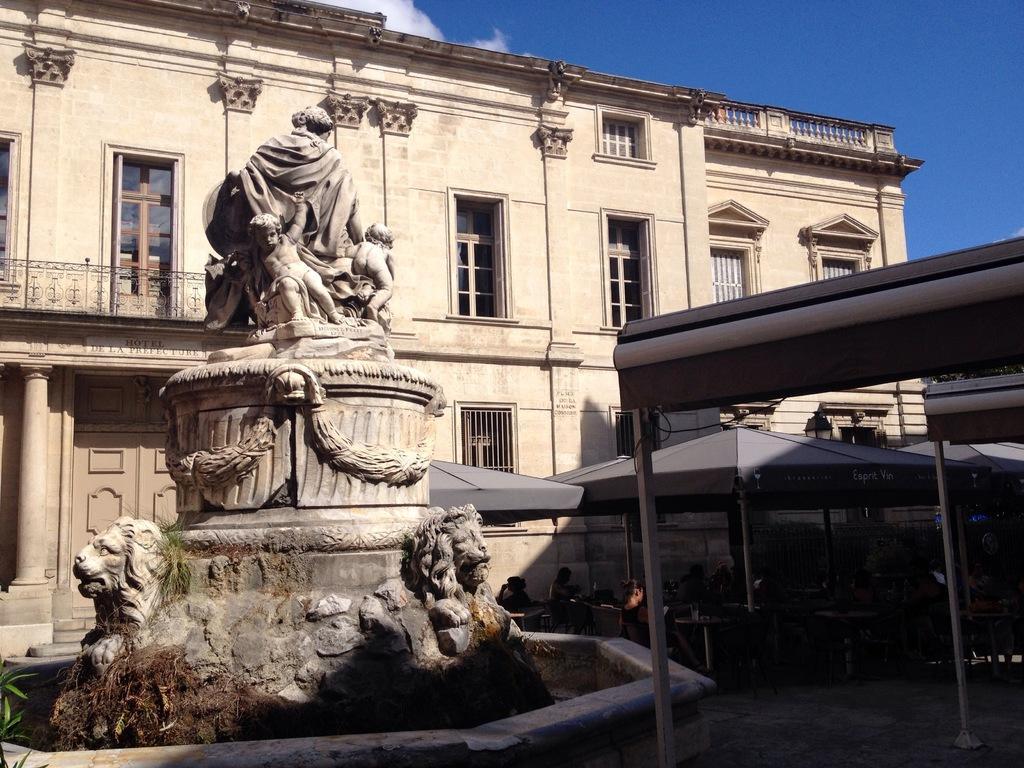In one or two sentences, can you explain what this image depicts? In this picture we can see a statue, tents, poles, building with windows and some people and in the background we can see the sky. 